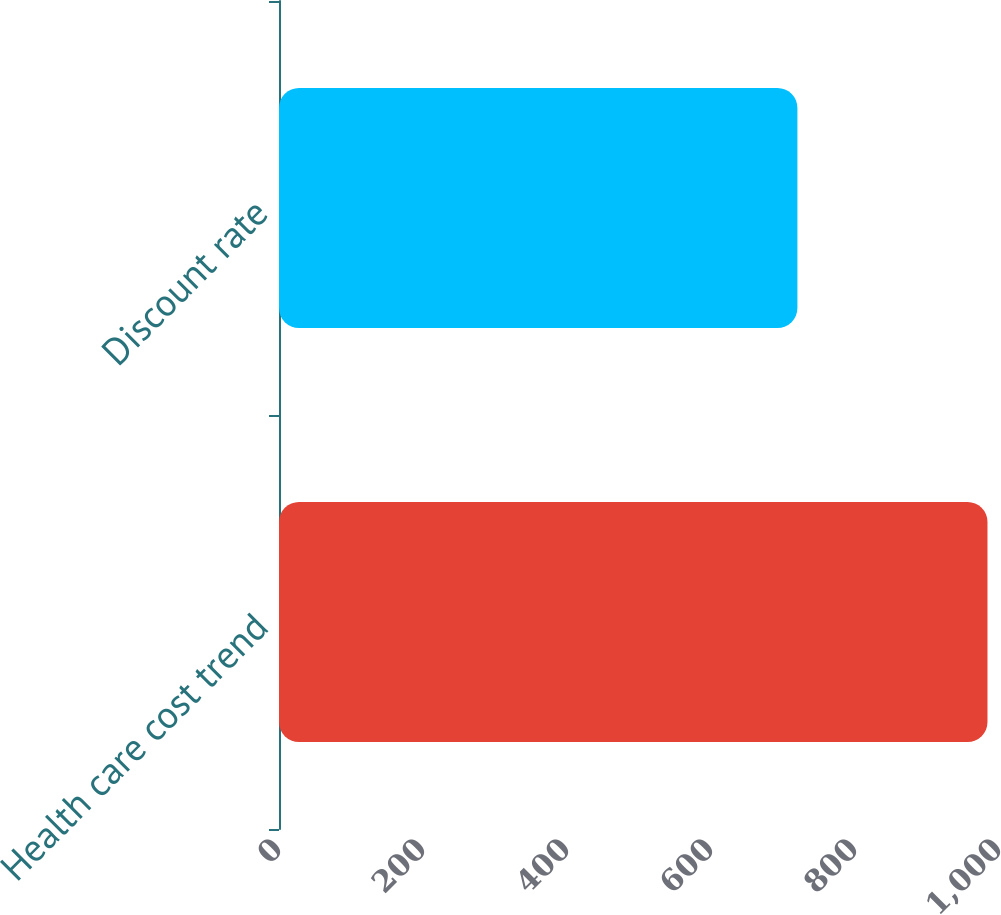Convert chart. <chart><loc_0><loc_0><loc_500><loc_500><bar_chart><fcel>Health care cost trend<fcel>Discount rate<nl><fcel>984<fcel>720<nl></chart> 